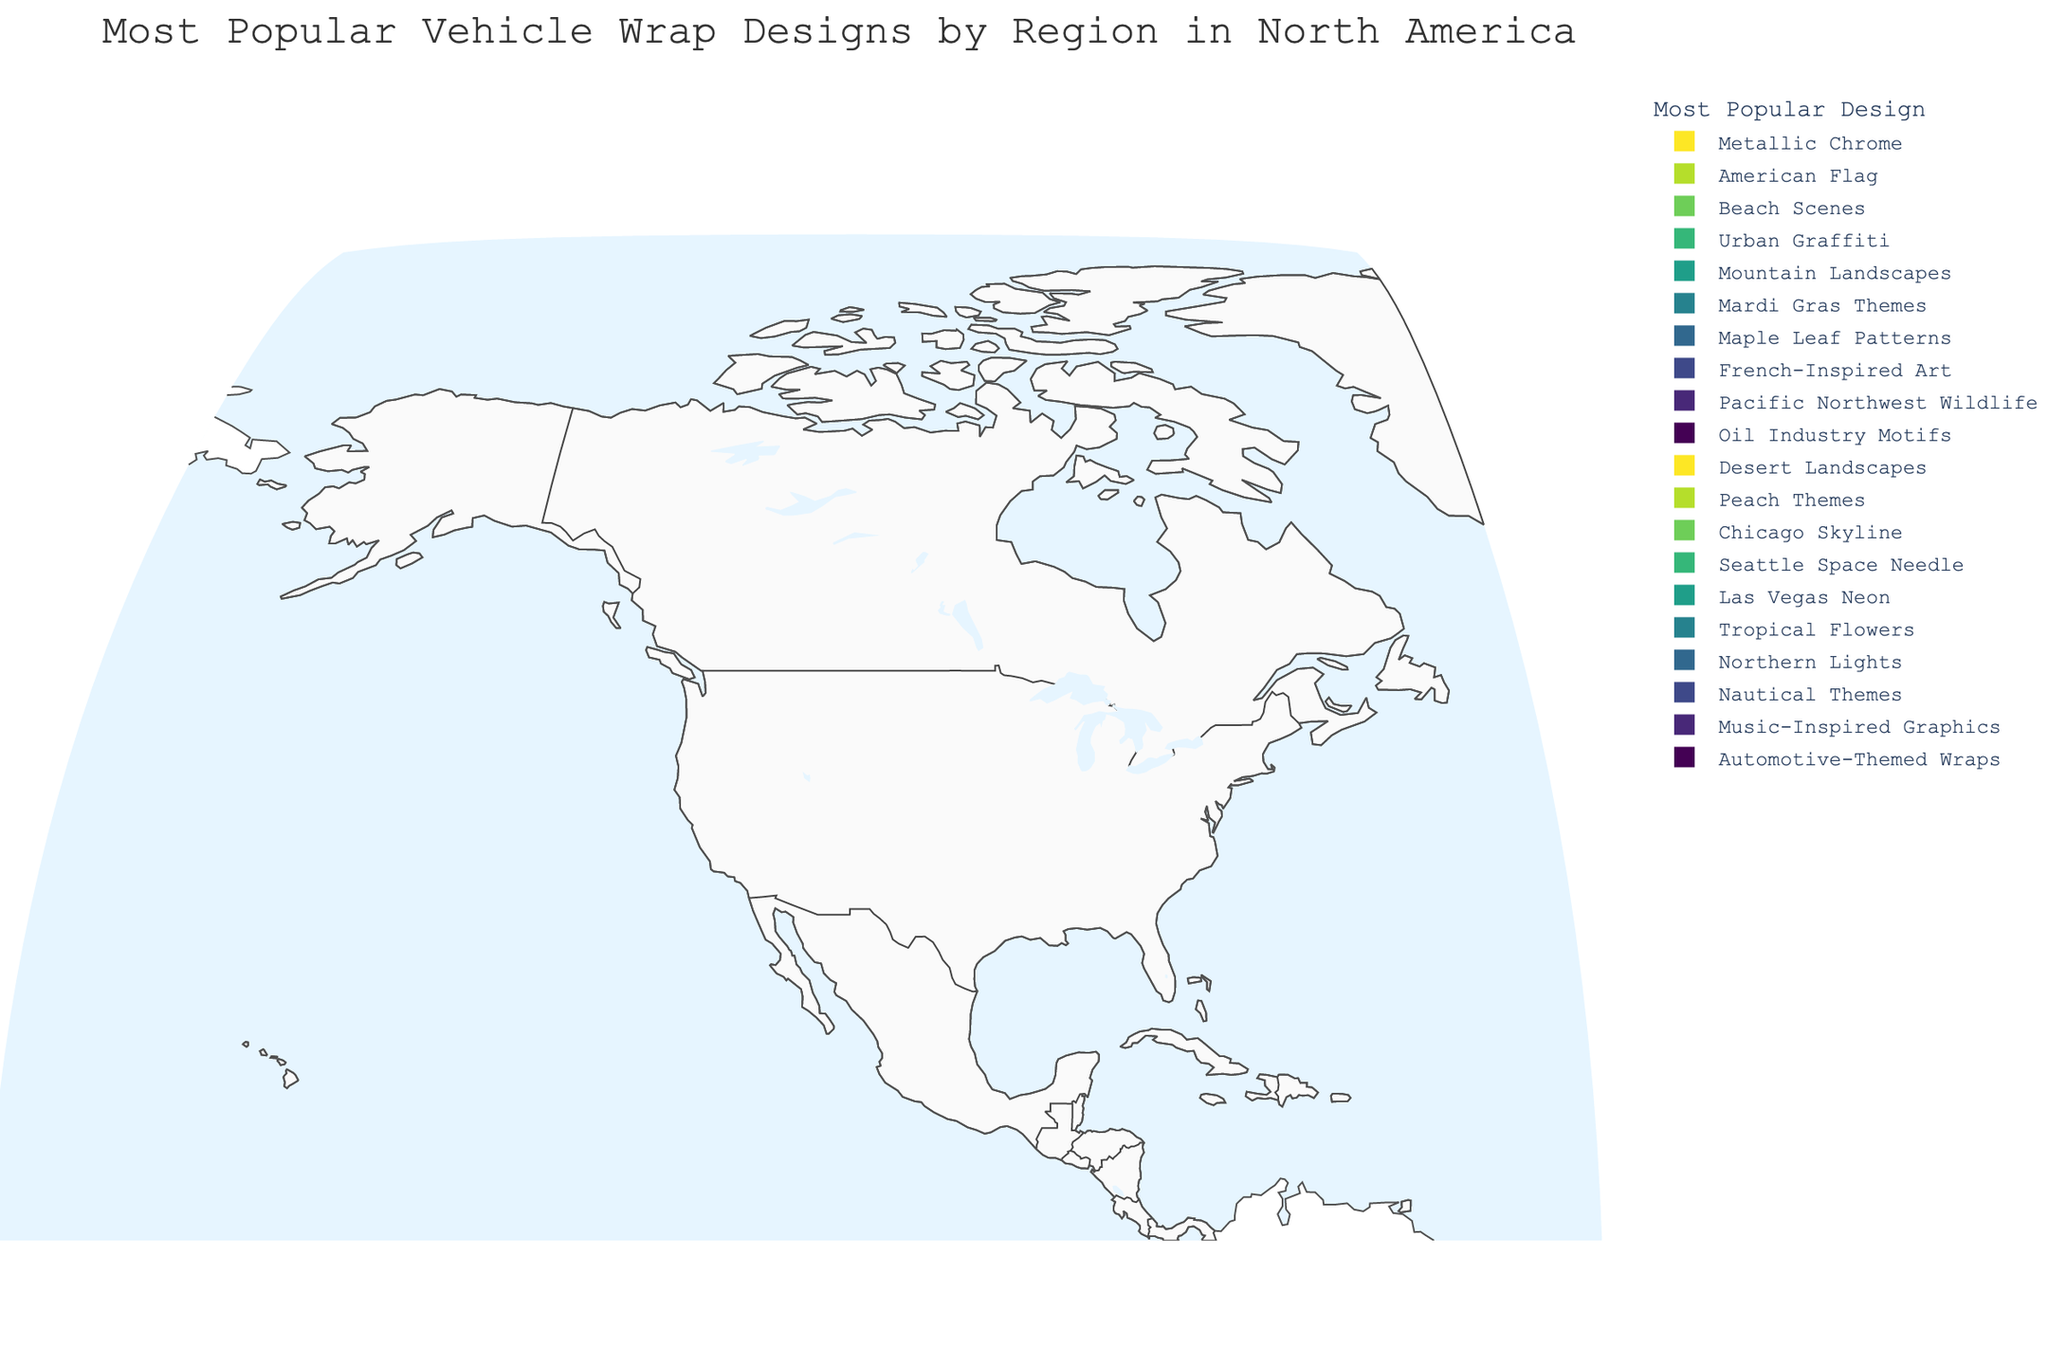What's the most popular vehicle wrap design in Texas? Look at the region labeled "Texas" and observe the corresponding wrap design from the color legend or hover information.
Answer: American Flag Which region prefers Mountain Landscapes vehicle wrap designs? Identify the region labeled with the "Mountain Landscapes" design by hovering over or checking the color legend and finding the associated state or province.
Answer: Colorado List two regions that have natural landscape-themed vehicle wrap designs. Scan the map for labels or hover information that mention natural landscapes, such as Desert Landscapes, Mountain Landscapes, Beach Scenes, etc.
Answer: Florida, Arizona What is the title of the geographic plot? The title is usually found at the top of the plot and gives an overall description of the visualized data.
Answer: Most Popular Vehicle Wrap Designs by Region in North America Compare the popularity of vehicle wrap designs between Nevada and New York. Find both Nevada and New York on the map, review their associated wrap designs through the hover information or color legend, and compare.
Answer: Nevada: Las Vegas Neon, New York: Urban Graffiti Identify a design that is popular in multiple regions. Observe the map for repeated vehicle wrap designs across different regions, utilizing hover information and color legend for verification.
Answer: None (Each region has a unique design) Which region has the most popular vehicle wrap design inspired by music? Look through the map or hover information to find the region with a design labeled as music-inspired.
Answer: Tennessee What type of design is preferred in Alaska? Locate Alaska on the map and use the hover information or color legend to identify its popular vehicle wrap design.
Answer: Northern Lights How many regions prefer vehicle wrap designs inspired by urban or city elements? Count the regions with designs that are urban or city-themed, using hover information or color legend for validation. Urban-centric designs might include references to city skylines, graffiti, etc.
Answer: 2 (New York - Urban Graffiti, Illinois - Chicago Skyline) Which state favors a vehicle wrap design related to oil industry motifs? Hover over the states and check the color legend to find the one associated with oil industry motifs.
Answer: Alberta 